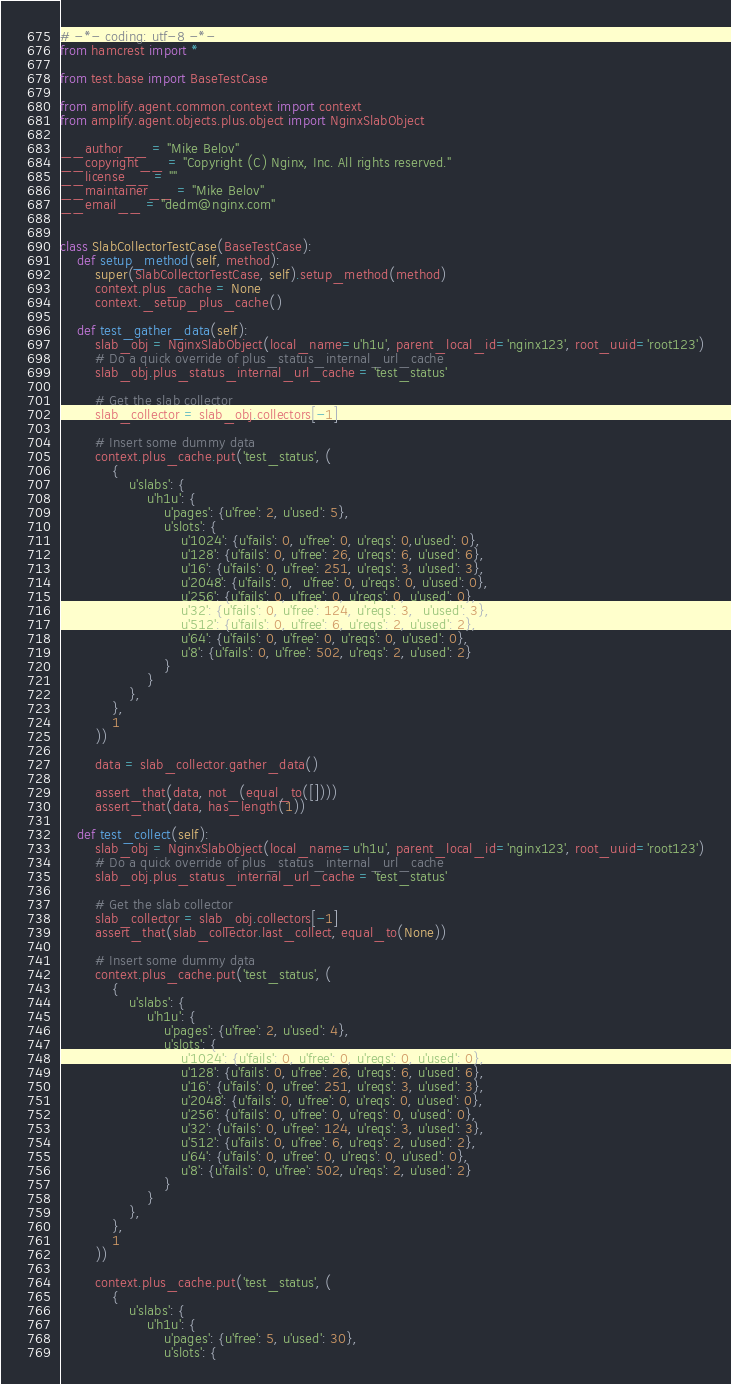<code> <loc_0><loc_0><loc_500><loc_500><_Python_># -*- coding: utf-8 -*-
from hamcrest import *

from test.base import BaseTestCase

from amplify.agent.common.context import context
from amplify.agent.objects.plus.object import NginxSlabObject

__author__ = "Mike Belov"
__copyright__ = "Copyright (C) Nginx, Inc. All rights reserved."
__license__ = ""
__maintainer__ = "Mike Belov"
__email__ = "dedm@nginx.com"


class SlabCollectorTestCase(BaseTestCase):
    def setup_method(self, method):
        super(SlabCollectorTestCase, self).setup_method(method)
        context.plus_cache = None
        context._setup_plus_cache()

    def test_gather_data(self):
        slab_obj = NginxSlabObject(local_name=u'h1u', parent_local_id='nginx123', root_uuid='root123')
        # Do a quick override of plus_status_internal_url_cache
        slab_obj.plus_status_internal_url_cache = 'test_status'

        # Get the slab collector
        slab_collector = slab_obj.collectors[-1]

        # Insert some dummy data
        context.plus_cache.put('test_status', (
            {
                u'slabs': {
                    u'h1u': {
                        u'pages': {u'free': 2, u'used': 5},
                        u'slots': {
                            u'1024': {u'fails': 0, u'free': 0, u'reqs': 0,u'used': 0},
                            u'128': {u'fails': 0, u'free': 26, u'reqs': 6, u'used': 6},
                            u'16': {u'fails': 0, u'free': 251, u'reqs': 3, u'used': 3},
                            u'2048': {u'fails': 0,  u'free': 0, u'reqs': 0, u'used': 0},
                            u'256': {u'fails': 0, u'free': 0, u'reqs': 0, u'used': 0},
                            u'32': {u'fails': 0, u'free': 124, u'reqs': 3,  u'used': 3},
                            u'512': {u'fails': 0, u'free': 6, u'reqs': 2, u'used': 2},
                            u'64': {u'fails': 0, u'free': 0, u'reqs': 0, u'used': 0},
                            u'8': {u'fails': 0, u'free': 502, u'reqs': 2, u'used': 2}
                        }
                    }
                },
            },
            1
        ))

        data = slab_collector.gather_data()

        assert_that(data, not_(equal_to([])))
        assert_that(data, has_length(1))

    def test_collect(self):
        slab_obj = NginxSlabObject(local_name=u'h1u', parent_local_id='nginx123', root_uuid='root123')
        # Do a quick override of plus_status_internal_url_cache
        slab_obj.plus_status_internal_url_cache = 'test_status'

        # Get the slab collector
        slab_collector = slab_obj.collectors[-1]
        assert_that(slab_collector.last_collect, equal_to(None))

        # Insert some dummy data
        context.plus_cache.put('test_status', (
            {
                u'slabs': {
                    u'h1u': {
                        u'pages': {u'free': 2, u'used': 4},
                        u'slots': {
                            u'1024': {u'fails': 0, u'free': 0, u'reqs': 0, u'used': 0},
                            u'128': {u'fails': 0, u'free': 26, u'reqs': 6, u'used': 6},
                            u'16': {u'fails': 0, u'free': 251, u'reqs': 3, u'used': 3},
                            u'2048': {u'fails': 0, u'free': 0, u'reqs': 0, u'used': 0},
                            u'256': {u'fails': 0, u'free': 0, u'reqs': 0, u'used': 0},
                            u'32': {u'fails': 0, u'free': 124, u'reqs': 3, u'used': 3},
                            u'512': {u'fails': 0, u'free': 6, u'reqs': 2, u'used': 2},
                            u'64': {u'fails': 0, u'free': 0, u'reqs': 0, u'used': 0},
                            u'8': {u'fails': 0, u'free': 502, u'reqs': 2, u'used': 2}
                        }
                    }
                },
            },
            1
        ))

        context.plus_cache.put('test_status', (
            {
                u'slabs': {
                    u'h1u': {
                        u'pages': {u'free': 5, u'used': 30},
                        u'slots': {</code> 